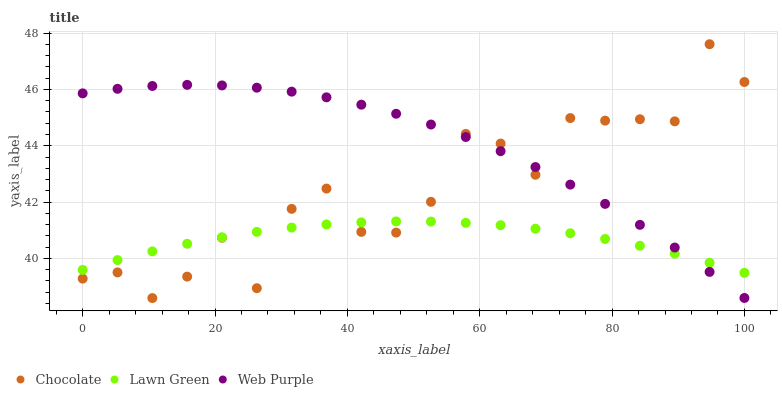Does Lawn Green have the minimum area under the curve?
Answer yes or no. Yes. Does Web Purple have the maximum area under the curve?
Answer yes or no. Yes. Does Chocolate have the minimum area under the curve?
Answer yes or no. No. Does Chocolate have the maximum area under the curve?
Answer yes or no. No. Is Lawn Green the smoothest?
Answer yes or no. Yes. Is Chocolate the roughest?
Answer yes or no. Yes. Is Web Purple the smoothest?
Answer yes or no. No. Is Web Purple the roughest?
Answer yes or no. No. Does Chocolate have the lowest value?
Answer yes or no. Yes. Does Web Purple have the lowest value?
Answer yes or no. No. Does Chocolate have the highest value?
Answer yes or no. Yes. Does Web Purple have the highest value?
Answer yes or no. No. Does Chocolate intersect Web Purple?
Answer yes or no. Yes. Is Chocolate less than Web Purple?
Answer yes or no. No. Is Chocolate greater than Web Purple?
Answer yes or no. No. 